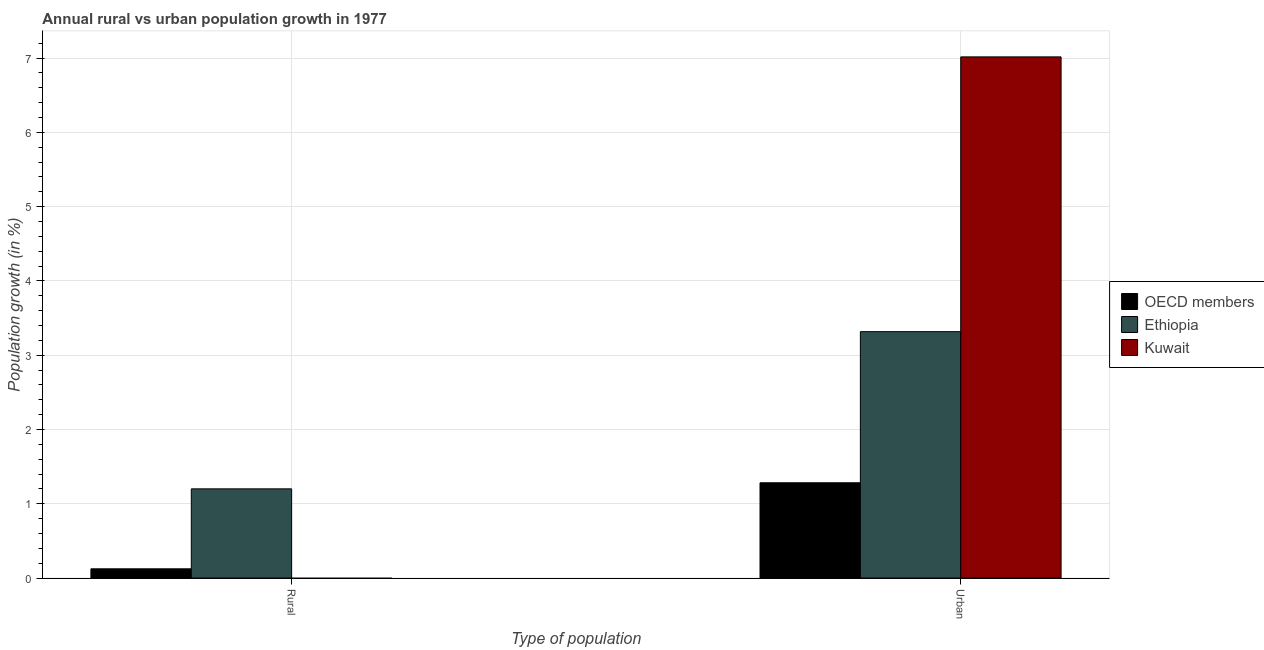How many groups of bars are there?
Ensure brevity in your answer.  2. Are the number of bars on each tick of the X-axis equal?
Your answer should be compact. No. How many bars are there on the 2nd tick from the left?
Keep it short and to the point. 3. How many bars are there on the 2nd tick from the right?
Offer a very short reply. 2. What is the label of the 2nd group of bars from the left?
Offer a terse response. Urban . What is the urban population growth in Ethiopia?
Keep it short and to the point. 3.32. Across all countries, what is the maximum rural population growth?
Provide a succinct answer. 1.2. Across all countries, what is the minimum rural population growth?
Provide a short and direct response. 0. In which country was the rural population growth maximum?
Ensure brevity in your answer.  Ethiopia. What is the total rural population growth in the graph?
Keep it short and to the point. 1.33. What is the difference between the urban population growth in Ethiopia and that in OECD members?
Your response must be concise. 2.03. What is the difference between the urban population growth in Kuwait and the rural population growth in Ethiopia?
Offer a very short reply. 5.82. What is the average urban population growth per country?
Make the answer very short. 3.87. What is the difference between the urban population growth and rural population growth in Ethiopia?
Offer a terse response. 2.12. What is the ratio of the rural population growth in OECD members to that in Ethiopia?
Make the answer very short. 0.1. Is the urban population growth in Ethiopia less than that in Kuwait?
Provide a short and direct response. Yes. In how many countries, is the rural population growth greater than the average rural population growth taken over all countries?
Your response must be concise. 1. How many bars are there?
Your response must be concise. 5. Are the values on the major ticks of Y-axis written in scientific E-notation?
Provide a short and direct response. No. Does the graph contain any zero values?
Make the answer very short. Yes. Does the graph contain grids?
Keep it short and to the point. Yes. How are the legend labels stacked?
Provide a succinct answer. Vertical. What is the title of the graph?
Ensure brevity in your answer.  Annual rural vs urban population growth in 1977. What is the label or title of the X-axis?
Offer a very short reply. Type of population. What is the label or title of the Y-axis?
Offer a very short reply. Population growth (in %). What is the Population growth (in %) of OECD members in Rural?
Your answer should be very brief. 0.12. What is the Population growth (in %) in Ethiopia in Rural?
Make the answer very short. 1.2. What is the Population growth (in %) in Kuwait in Rural?
Your response must be concise. 0. What is the Population growth (in %) in OECD members in Urban ?
Your response must be concise. 1.28. What is the Population growth (in %) in Ethiopia in Urban ?
Ensure brevity in your answer.  3.32. What is the Population growth (in %) of Kuwait in Urban ?
Ensure brevity in your answer.  7.02. Across all Type of population, what is the maximum Population growth (in %) in OECD members?
Your answer should be very brief. 1.28. Across all Type of population, what is the maximum Population growth (in %) in Ethiopia?
Offer a terse response. 3.32. Across all Type of population, what is the maximum Population growth (in %) in Kuwait?
Your response must be concise. 7.02. Across all Type of population, what is the minimum Population growth (in %) in OECD members?
Provide a succinct answer. 0.12. Across all Type of population, what is the minimum Population growth (in %) of Ethiopia?
Provide a succinct answer. 1.2. Across all Type of population, what is the minimum Population growth (in %) in Kuwait?
Provide a succinct answer. 0. What is the total Population growth (in %) of OECD members in the graph?
Your answer should be very brief. 1.41. What is the total Population growth (in %) of Ethiopia in the graph?
Give a very brief answer. 4.52. What is the total Population growth (in %) of Kuwait in the graph?
Your answer should be very brief. 7.02. What is the difference between the Population growth (in %) in OECD members in Rural and that in Urban ?
Provide a succinct answer. -1.16. What is the difference between the Population growth (in %) in Ethiopia in Rural and that in Urban ?
Your answer should be very brief. -2.12. What is the difference between the Population growth (in %) of OECD members in Rural and the Population growth (in %) of Ethiopia in Urban?
Ensure brevity in your answer.  -3.19. What is the difference between the Population growth (in %) in OECD members in Rural and the Population growth (in %) in Kuwait in Urban?
Your answer should be very brief. -6.89. What is the difference between the Population growth (in %) in Ethiopia in Rural and the Population growth (in %) in Kuwait in Urban?
Keep it short and to the point. -5.82. What is the average Population growth (in %) of OECD members per Type of population?
Keep it short and to the point. 0.7. What is the average Population growth (in %) of Ethiopia per Type of population?
Give a very brief answer. 2.26. What is the average Population growth (in %) in Kuwait per Type of population?
Provide a succinct answer. 3.51. What is the difference between the Population growth (in %) in OECD members and Population growth (in %) in Ethiopia in Rural?
Ensure brevity in your answer.  -1.08. What is the difference between the Population growth (in %) of OECD members and Population growth (in %) of Ethiopia in Urban ?
Provide a succinct answer. -2.03. What is the difference between the Population growth (in %) in OECD members and Population growth (in %) in Kuwait in Urban ?
Your answer should be compact. -5.73. What is the difference between the Population growth (in %) in Ethiopia and Population growth (in %) in Kuwait in Urban ?
Keep it short and to the point. -3.7. What is the ratio of the Population growth (in %) in OECD members in Rural to that in Urban ?
Give a very brief answer. 0.1. What is the ratio of the Population growth (in %) of Ethiopia in Rural to that in Urban ?
Ensure brevity in your answer.  0.36. What is the difference between the highest and the second highest Population growth (in %) in OECD members?
Provide a succinct answer. 1.16. What is the difference between the highest and the second highest Population growth (in %) of Ethiopia?
Your answer should be very brief. 2.12. What is the difference between the highest and the lowest Population growth (in %) in OECD members?
Ensure brevity in your answer.  1.16. What is the difference between the highest and the lowest Population growth (in %) in Ethiopia?
Provide a short and direct response. 2.12. What is the difference between the highest and the lowest Population growth (in %) of Kuwait?
Your answer should be very brief. 7.02. 